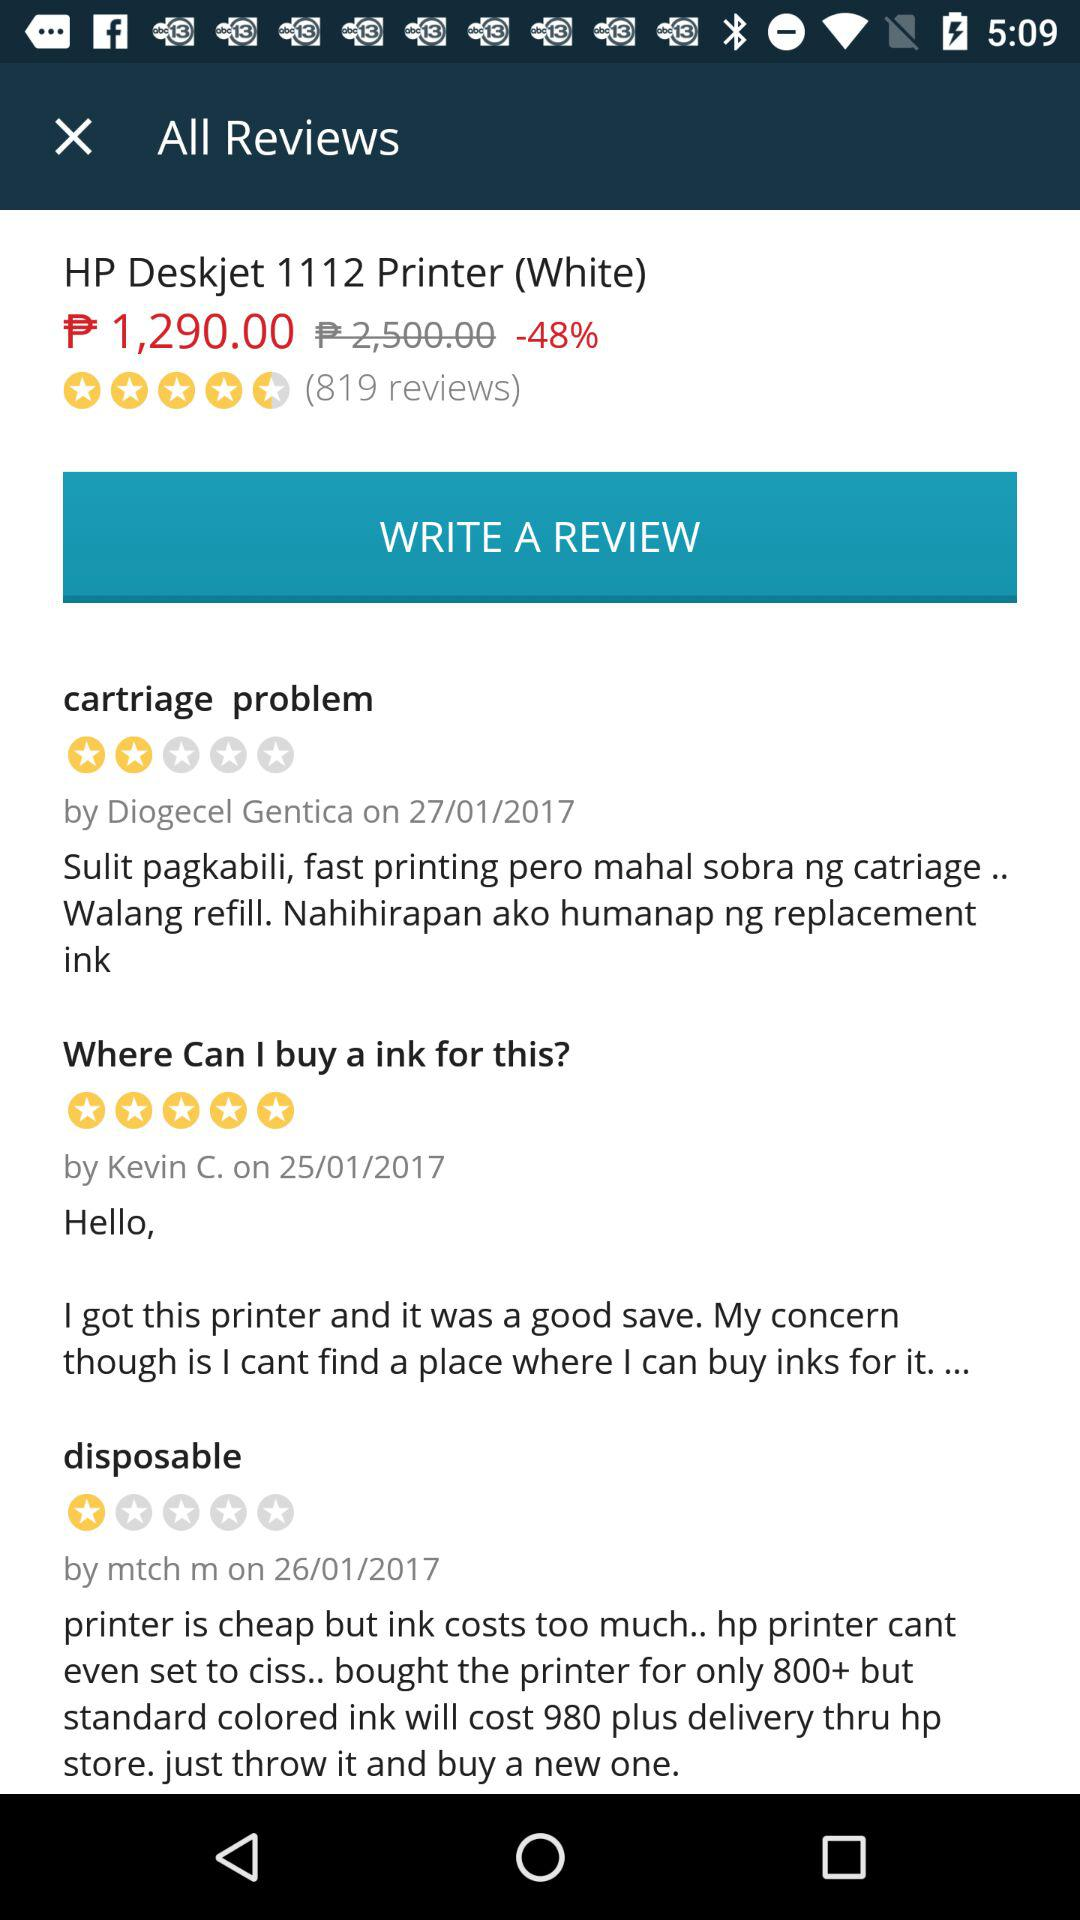After the discount, what is the price of the "HP Deskjet 1112 Printer"? The price is ₱1,290.00. 